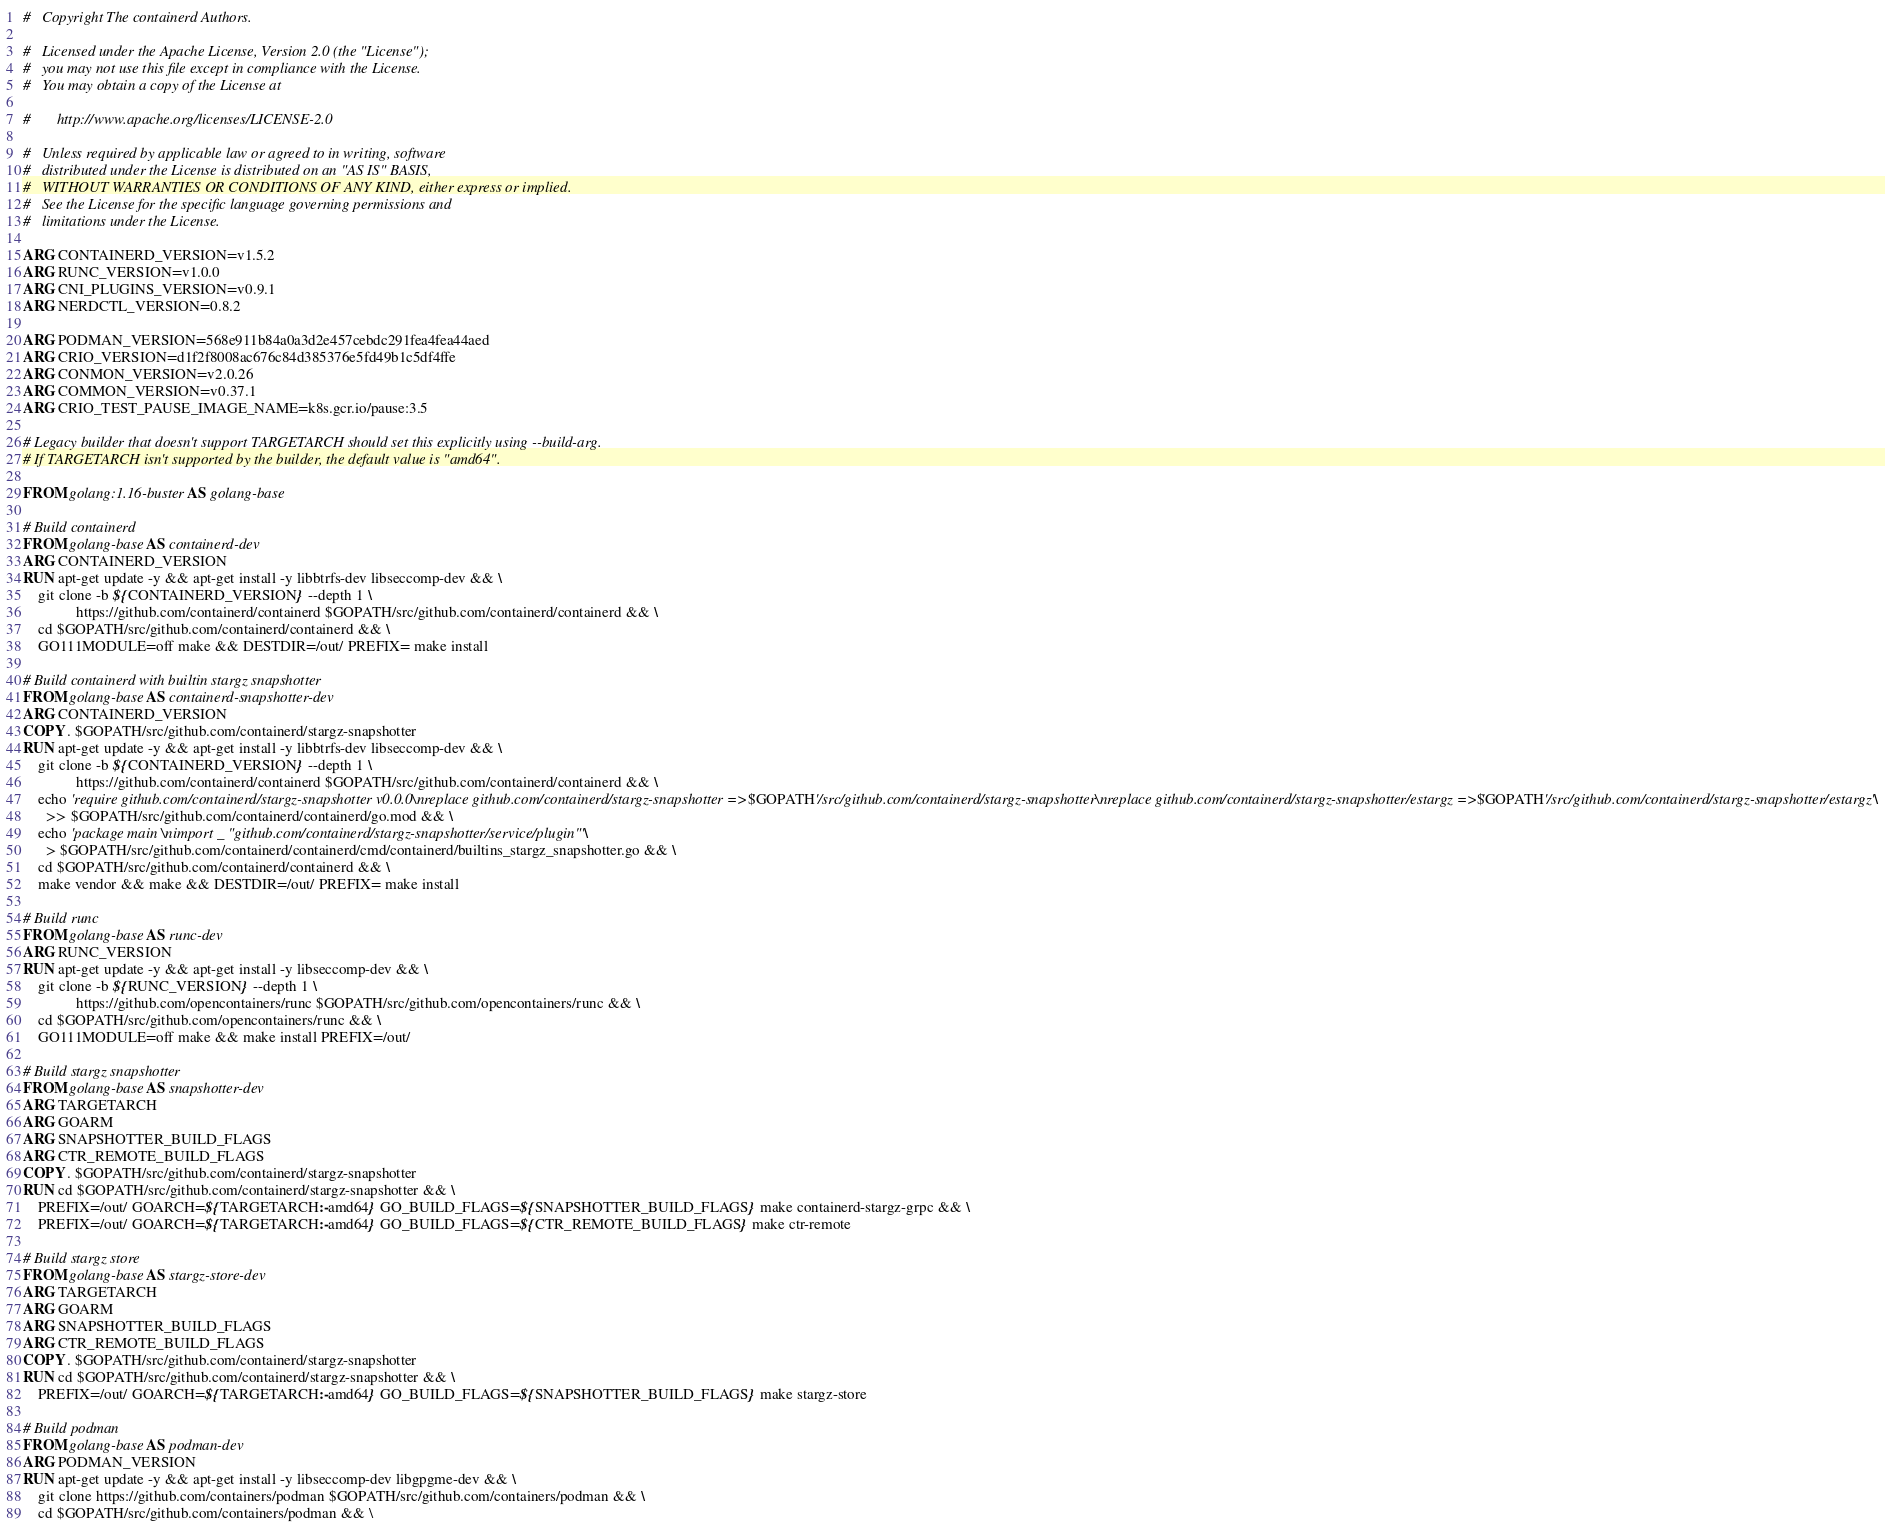Convert code to text. <code><loc_0><loc_0><loc_500><loc_500><_Dockerfile_>#   Copyright The containerd Authors.

#   Licensed under the Apache License, Version 2.0 (the "License");
#   you may not use this file except in compliance with the License.
#   You may obtain a copy of the License at

#       http://www.apache.org/licenses/LICENSE-2.0

#   Unless required by applicable law or agreed to in writing, software
#   distributed under the License is distributed on an "AS IS" BASIS,
#   WITHOUT WARRANTIES OR CONDITIONS OF ANY KIND, either express or implied.
#   See the License for the specific language governing permissions and
#   limitations under the License.

ARG CONTAINERD_VERSION=v1.5.2
ARG RUNC_VERSION=v1.0.0
ARG CNI_PLUGINS_VERSION=v0.9.1
ARG NERDCTL_VERSION=0.8.2

ARG PODMAN_VERSION=568e911b84a0a3d2e457cebdc291fea4fea44aed
ARG CRIO_VERSION=d1f2f8008ac676c84d385376e5fd49b1c5df4ffe
ARG CONMON_VERSION=v2.0.26
ARG COMMON_VERSION=v0.37.1
ARG CRIO_TEST_PAUSE_IMAGE_NAME=k8s.gcr.io/pause:3.5

# Legacy builder that doesn't support TARGETARCH should set this explicitly using --build-arg.
# If TARGETARCH isn't supported by the builder, the default value is "amd64".

FROM golang:1.16-buster AS golang-base

# Build containerd
FROM golang-base AS containerd-dev
ARG CONTAINERD_VERSION
RUN apt-get update -y && apt-get install -y libbtrfs-dev libseccomp-dev && \
    git clone -b ${CONTAINERD_VERSION} --depth 1 \
              https://github.com/containerd/containerd $GOPATH/src/github.com/containerd/containerd && \
    cd $GOPATH/src/github.com/containerd/containerd && \
    GO111MODULE=off make && DESTDIR=/out/ PREFIX= make install

# Build containerd with builtin stargz snapshotter
FROM golang-base AS containerd-snapshotter-dev
ARG CONTAINERD_VERSION
COPY . $GOPATH/src/github.com/containerd/stargz-snapshotter
RUN apt-get update -y && apt-get install -y libbtrfs-dev libseccomp-dev && \
    git clone -b ${CONTAINERD_VERSION} --depth 1 \
              https://github.com/containerd/containerd $GOPATH/src/github.com/containerd/containerd && \
    echo 'require github.com/containerd/stargz-snapshotter v0.0.0\nreplace github.com/containerd/stargz-snapshotter => '$GOPATH'/src/github.com/containerd/stargz-snapshotter\nreplace github.com/containerd/stargz-snapshotter/estargz => '$GOPATH'/src/github.com/containerd/stargz-snapshotter/estargz' \
      >> $GOPATH/src/github.com/containerd/containerd/go.mod && \
    echo 'package main \nimport _ "github.com/containerd/stargz-snapshotter/service/plugin"' \
      > $GOPATH/src/github.com/containerd/containerd/cmd/containerd/builtins_stargz_snapshotter.go && \
    cd $GOPATH/src/github.com/containerd/containerd && \
    make vendor && make && DESTDIR=/out/ PREFIX= make install

# Build runc
FROM golang-base AS runc-dev
ARG RUNC_VERSION
RUN apt-get update -y && apt-get install -y libseccomp-dev && \
    git clone -b ${RUNC_VERSION} --depth 1 \
              https://github.com/opencontainers/runc $GOPATH/src/github.com/opencontainers/runc && \
    cd $GOPATH/src/github.com/opencontainers/runc && \
    GO111MODULE=off make && make install PREFIX=/out/

# Build stargz snapshotter
FROM golang-base AS snapshotter-dev
ARG TARGETARCH
ARG GOARM
ARG SNAPSHOTTER_BUILD_FLAGS
ARG CTR_REMOTE_BUILD_FLAGS
COPY . $GOPATH/src/github.com/containerd/stargz-snapshotter
RUN cd $GOPATH/src/github.com/containerd/stargz-snapshotter && \
    PREFIX=/out/ GOARCH=${TARGETARCH:-amd64} GO_BUILD_FLAGS=${SNAPSHOTTER_BUILD_FLAGS} make containerd-stargz-grpc && \
    PREFIX=/out/ GOARCH=${TARGETARCH:-amd64} GO_BUILD_FLAGS=${CTR_REMOTE_BUILD_FLAGS} make ctr-remote

# Build stargz store
FROM golang-base AS stargz-store-dev
ARG TARGETARCH
ARG GOARM
ARG SNAPSHOTTER_BUILD_FLAGS
ARG CTR_REMOTE_BUILD_FLAGS
COPY . $GOPATH/src/github.com/containerd/stargz-snapshotter
RUN cd $GOPATH/src/github.com/containerd/stargz-snapshotter && \
    PREFIX=/out/ GOARCH=${TARGETARCH:-amd64} GO_BUILD_FLAGS=${SNAPSHOTTER_BUILD_FLAGS} make stargz-store

# Build podman
FROM golang-base AS podman-dev
ARG PODMAN_VERSION
RUN apt-get update -y && apt-get install -y libseccomp-dev libgpgme-dev && \
    git clone https://github.com/containers/podman $GOPATH/src/github.com/containers/podman && \
    cd $GOPATH/src/github.com/containers/podman && \</code> 